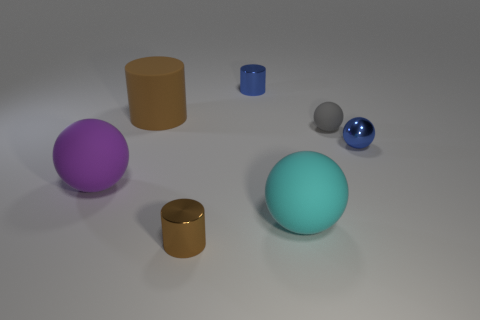There is a shiny object that is the same color as the big cylinder; what shape is it?
Offer a terse response. Cylinder. Does the brown rubber object have the same shape as the tiny matte thing?
Ensure brevity in your answer.  No. What number of things are cylinders that are in front of the large brown rubber thing or cubes?
Keep it short and to the point. 1. Are there the same number of small shiny objects that are behind the metal sphere and tiny metallic objects that are on the left side of the purple matte sphere?
Your response must be concise. No. What number of other objects are there of the same shape as the big cyan matte thing?
Provide a short and direct response. 3. There is a brown cylinder behind the purple matte ball; is it the same size as the blue object that is behind the gray sphere?
Make the answer very short. No. What number of balls are either large rubber objects or rubber objects?
Offer a very short reply. 3. How many metal things are either tiny blue objects or brown cubes?
Your response must be concise. 2. There is a purple rubber object that is the same shape as the big cyan matte thing; what size is it?
Your answer should be very brief. Large. There is a blue metal cylinder; is it the same size as the shiny cylinder that is in front of the small matte ball?
Ensure brevity in your answer.  Yes. 